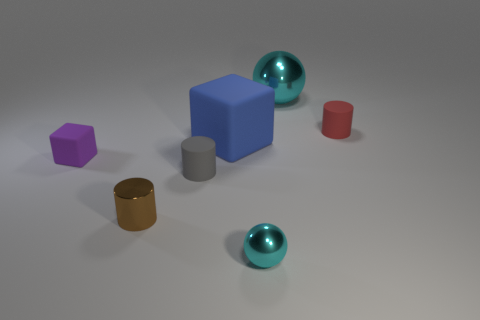What number of objects are large blue blocks or small metallic cylinders?
Provide a short and direct response. 2. How many large things have the same color as the tiny sphere?
Provide a short and direct response. 1. There is a purple matte thing that is the same size as the brown metallic thing; what shape is it?
Make the answer very short. Cube. Is there a small rubber object of the same shape as the big rubber object?
Your response must be concise. Yes. What number of spheres are made of the same material as the brown cylinder?
Offer a very short reply. 2. Are the ball that is in front of the tiny brown shiny cylinder and the big sphere made of the same material?
Make the answer very short. Yes. Is the number of tiny gray matte cylinders that are in front of the tiny cyan metallic sphere greater than the number of rubber things that are in front of the gray matte cylinder?
Keep it short and to the point. No. There is a brown cylinder that is the same size as the red rubber cylinder; what material is it?
Keep it short and to the point. Metal. What number of other objects are there of the same material as the gray cylinder?
Offer a very short reply. 3. Is the shape of the cyan shiny thing that is behind the tiny cyan metal ball the same as the cyan metal object that is in front of the big cyan sphere?
Your response must be concise. Yes. 